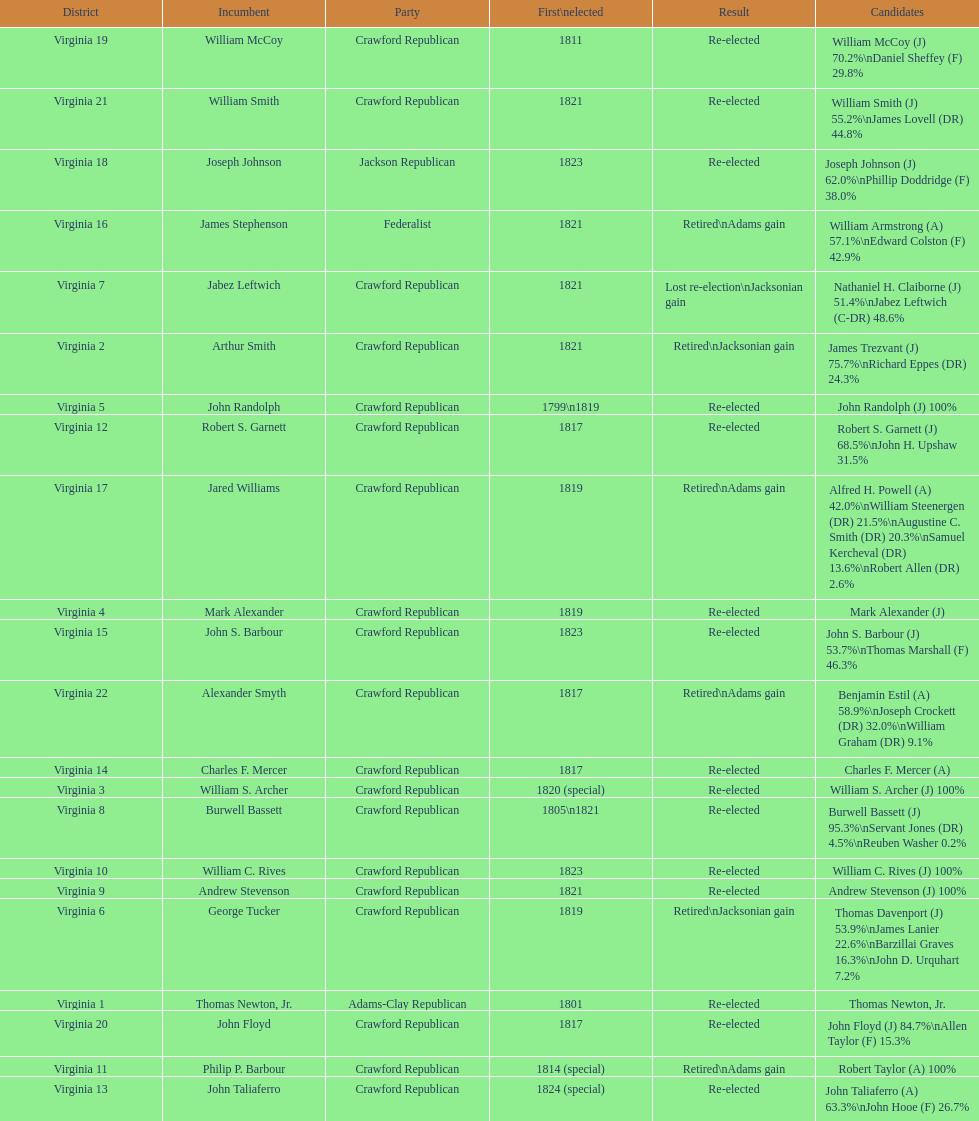What is the final party listed on this chart? Crawford Republican. 